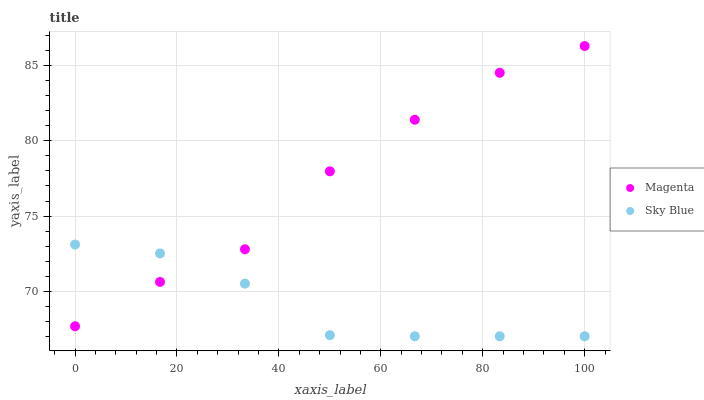Does Sky Blue have the minimum area under the curve?
Answer yes or no. Yes. Does Magenta have the maximum area under the curve?
Answer yes or no. Yes. Does Magenta have the minimum area under the curve?
Answer yes or no. No. Is Sky Blue the smoothest?
Answer yes or no. Yes. Is Magenta the roughest?
Answer yes or no. Yes. Is Magenta the smoothest?
Answer yes or no. No. Does Sky Blue have the lowest value?
Answer yes or no. Yes. Does Magenta have the lowest value?
Answer yes or no. No. Does Magenta have the highest value?
Answer yes or no. Yes. Does Magenta intersect Sky Blue?
Answer yes or no. Yes. Is Magenta less than Sky Blue?
Answer yes or no. No. Is Magenta greater than Sky Blue?
Answer yes or no. No. 